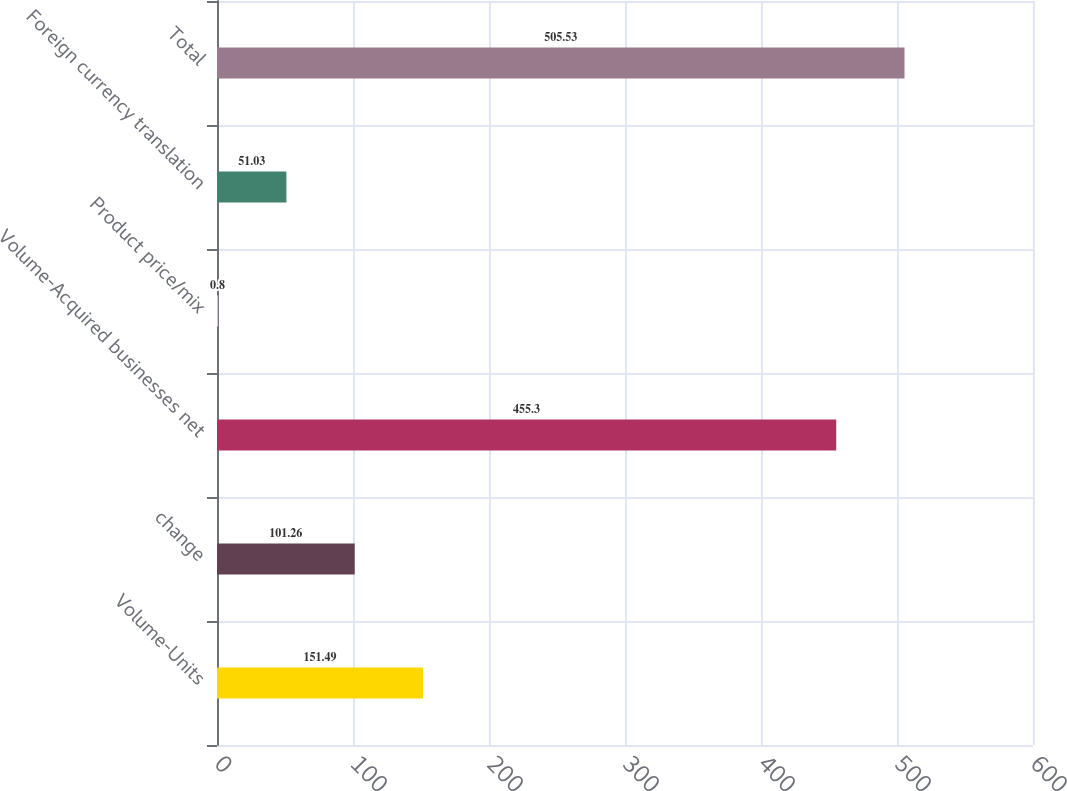<chart> <loc_0><loc_0><loc_500><loc_500><bar_chart><fcel>Volume-Units<fcel>change<fcel>Volume-Acquired businesses net<fcel>Product price/mix<fcel>Foreign currency translation<fcel>Total<nl><fcel>151.49<fcel>101.26<fcel>455.3<fcel>0.8<fcel>51.03<fcel>505.53<nl></chart> 